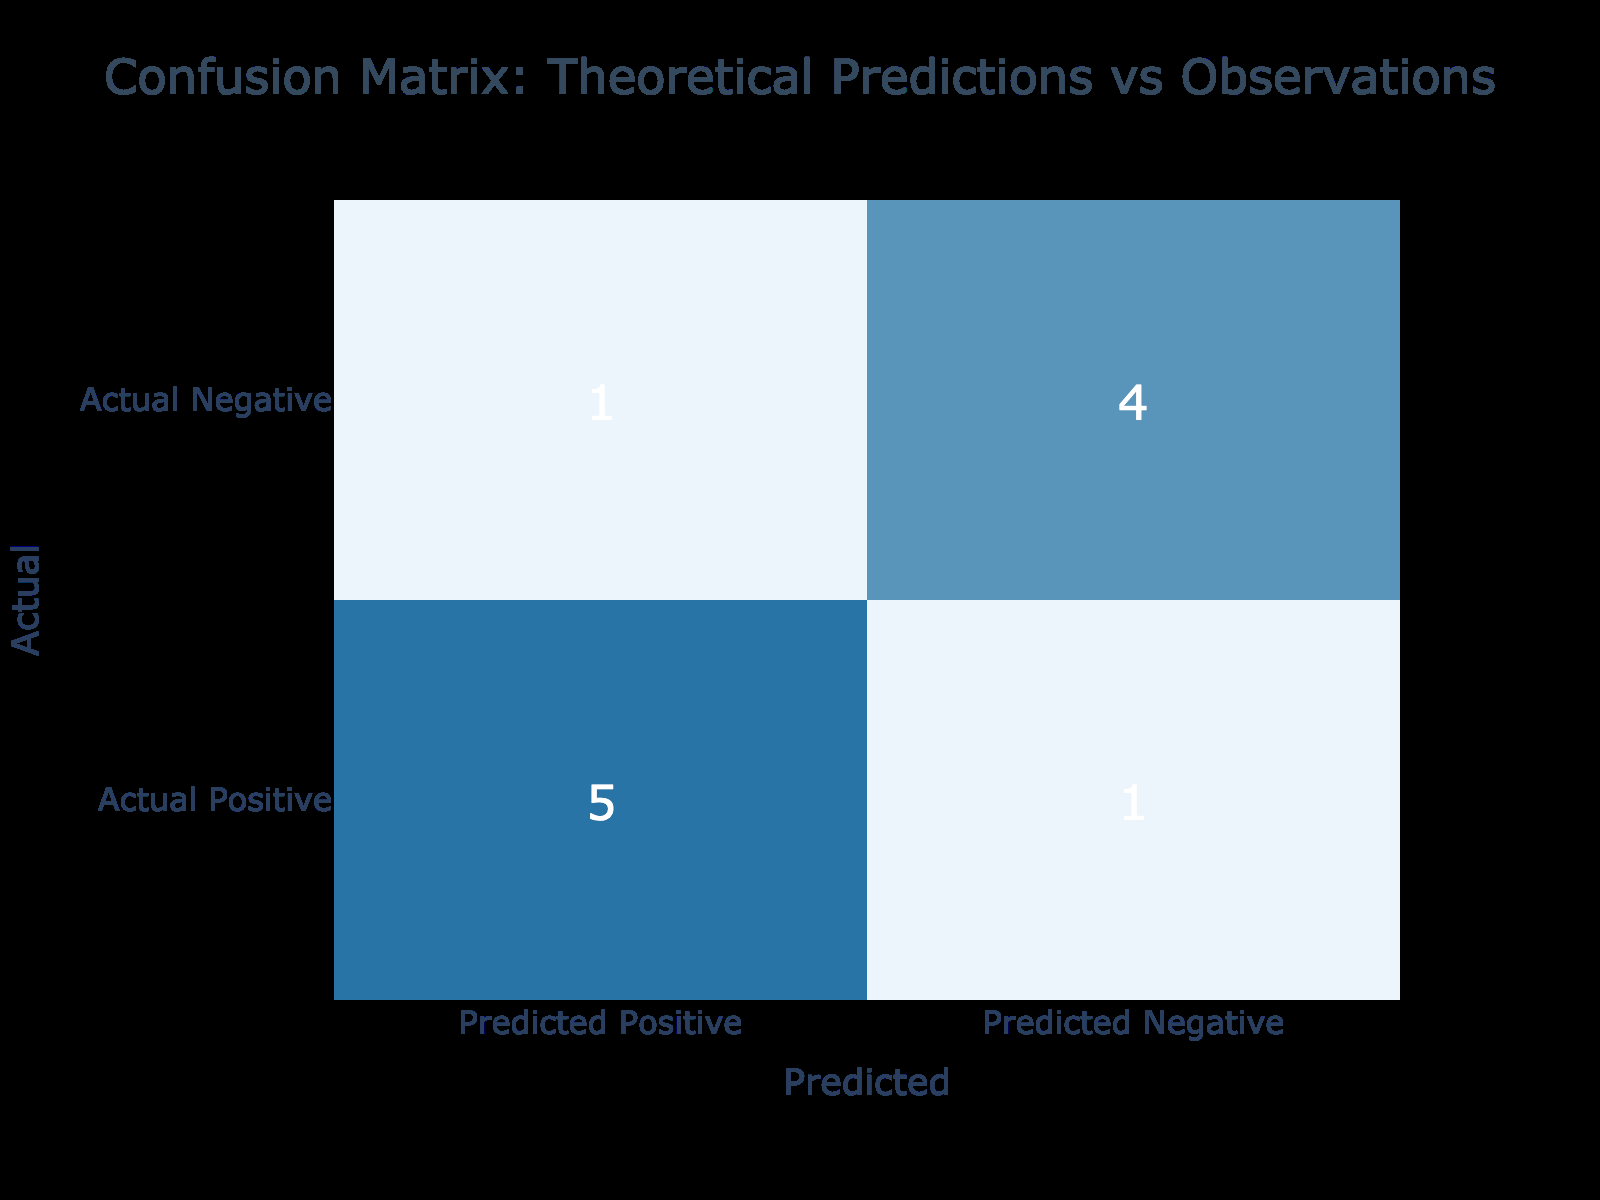What is the total number of True Positives in the table? To find the total number of True Positives, we sum the True Positive values from all relevant rows in the table. The relevant rows are: Higgs Boson Production (1), Cosmic Microwave Background Anisotropies (1), Gravitational Waves (1), Dark Matter Evidence in Clusters (1), Neutrino Oscillation (1). So, the total is 1 + 1 + 1 + 1 + 1 = 5.
Answer: 5 How many instances were correctly predicted as negative? To determine the number of instances correctly predicted as negative, we look at the True Negative values in the table. The relevant rows are: Galaxy Rotation Curves (1), Star Formation Rate in Early Universe (1), Expansion Rate of Universe (1), and Magnetic Monopoles (1). Thus, the total is 1 + 1 + 1 + 1 = 4.
Answer: 4 Is there any False Positive reported in the table? By scanning the table for the False Positive values, we can see that there is one False Positive in the row for Black Hole Formation, where it is indicated as 1. Therefore, the answer is yes.
Answer: Yes What is the total number of False Negatives? To find the total number of False Negatives, we must add the False Negative values from the relevant rows in the table. The only row with a False Negative is the Black Hole Formation (1). Hence, the total is 1.
Answer: 1 How does the number of True Positives compare to False Negatives? The number of True Positives is 5, while the number of False Negatives is 1 (previously calculated). Thus, comparing these two values, we see that True Positives (5) are much greater than False Negatives (1).
Answer: True Positives are greater What is the sum of True Negatives and False Positives? We can sum the True Negative and False Positive values from the table. True Negatives include Galaxy Rotation Curves (1), Star Formation Rate in Early Universe (1), Expansion Rate of Universe (1), and Magnetic Monopoles (1), totaling 4. The False Positive is only from Black Hole Formation (1). Therefore, 4 + 1 = 5.
Answer: 5 What does it suggest if both True Positives and True Negatives are low? If both True Positives and True Negatives are low, it suggests that the model is not performing well in terms of correctly predicting outcomes and identifying negative cases. It may indicate a problem with the theoretical predictions or the observational methods used. This could reflect limitations in data or discrepancies between theory and observation.
Answer: Poor model performance Do any theoretical predictions result in both False Positives and False Negatives? By examining the table, we see that Black Hole Formation has a False Positive (1) and a False Negative (1). This indicates the theoretical predictions for this phenomenon have greater discrepancy, resulting in both misclassifications. Hence, the answer is yes.
Answer: Yes 